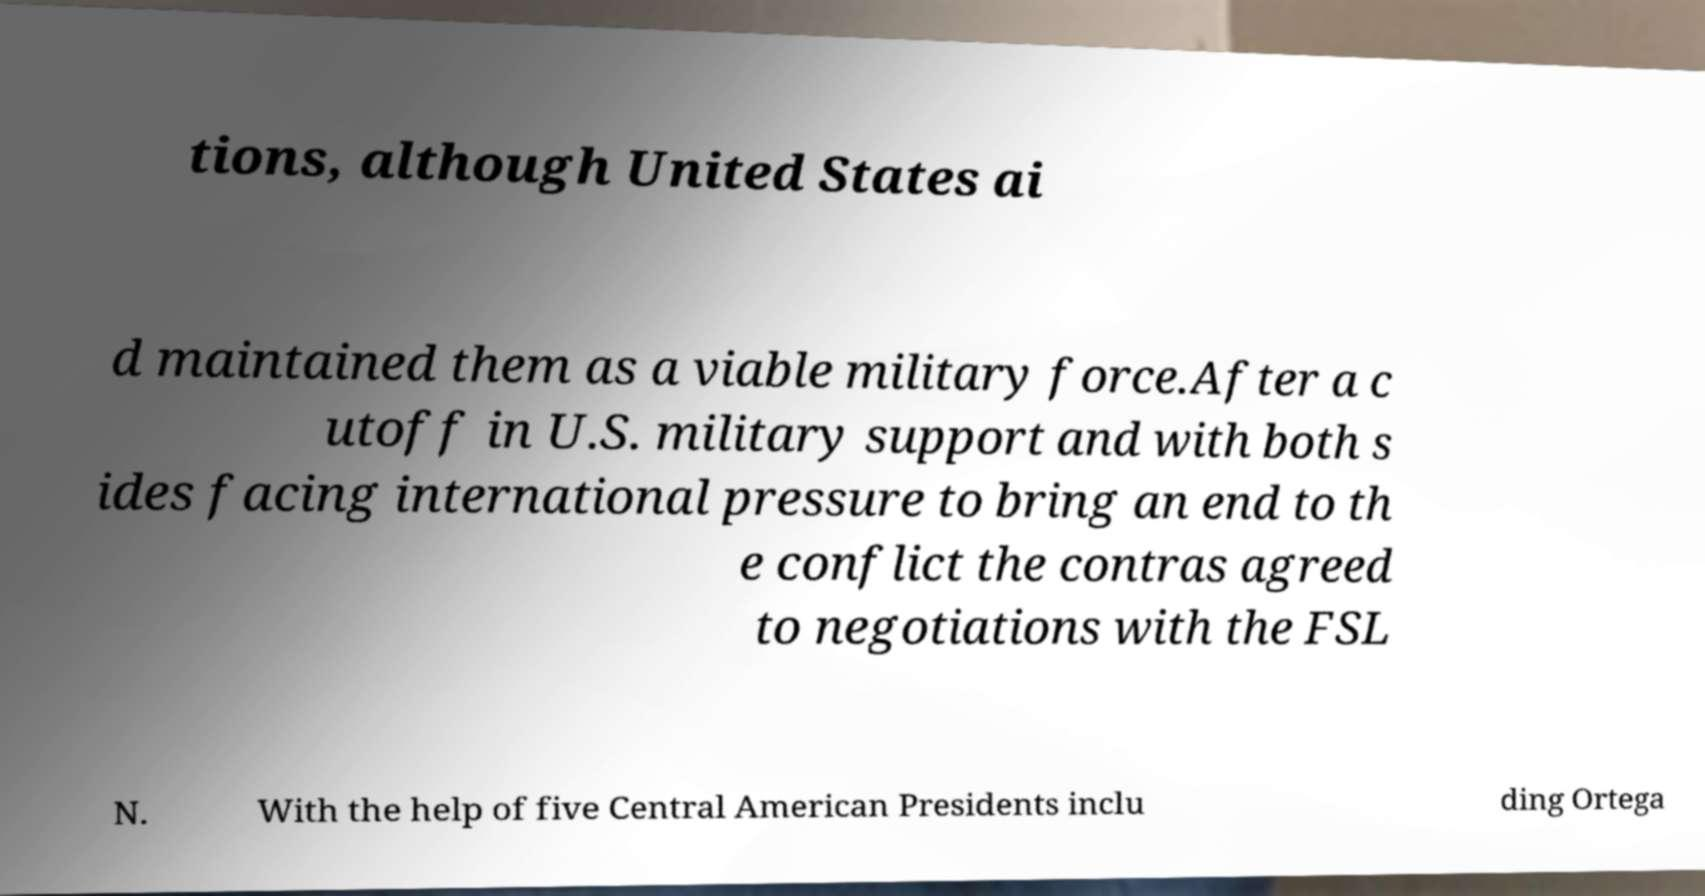Please identify and transcribe the text found in this image. tions, although United States ai d maintained them as a viable military force.After a c utoff in U.S. military support and with both s ides facing international pressure to bring an end to th e conflict the contras agreed to negotiations with the FSL N. With the help of five Central American Presidents inclu ding Ortega 